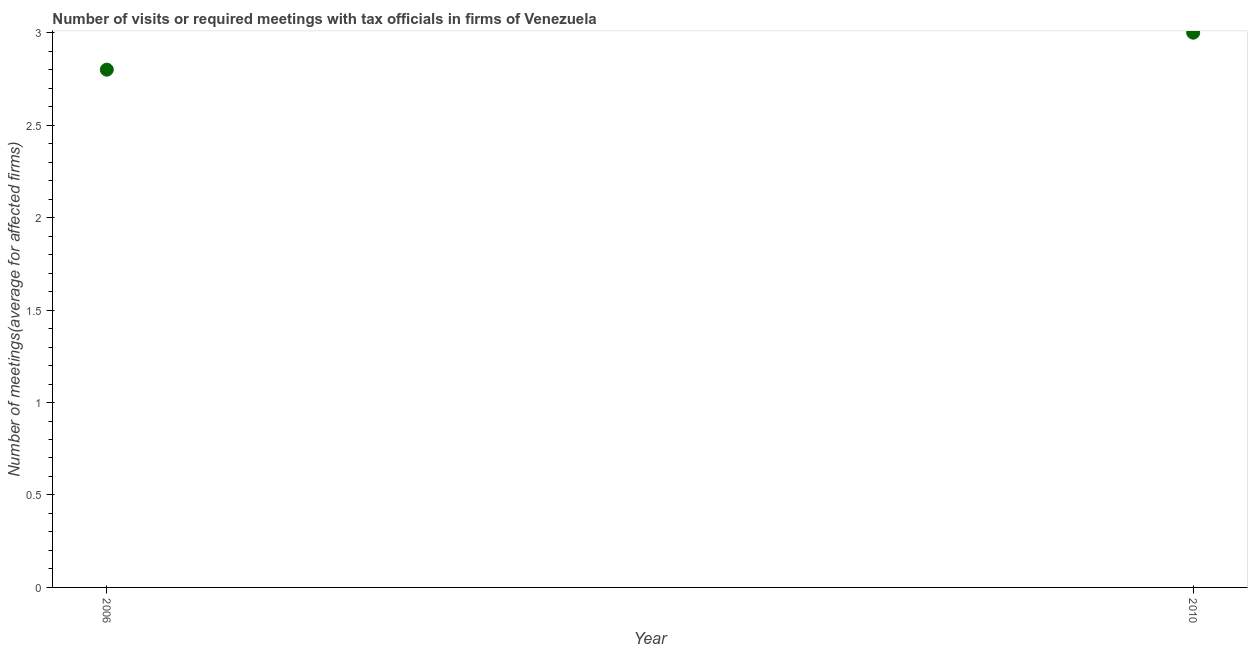What is the number of required meetings with tax officials in 2006?
Provide a succinct answer. 2.8. Across all years, what is the maximum number of required meetings with tax officials?
Offer a very short reply. 3. In which year was the number of required meetings with tax officials minimum?
Your response must be concise. 2006. What is the difference between the number of required meetings with tax officials in 2006 and 2010?
Provide a short and direct response. -0.2. In how many years, is the number of required meetings with tax officials greater than 0.7 ?
Provide a short and direct response. 2. What is the ratio of the number of required meetings with tax officials in 2006 to that in 2010?
Ensure brevity in your answer.  0.93. In how many years, is the number of required meetings with tax officials greater than the average number of required meetings with tax officials taken over all years?
Provide a succinct answer. 1. Does the number of required meetings with tax officials monotonically increase over the years?
Keep it short and to the point. Yes. How many dotlines are there?
Offer a terse response. 1. How many years are there in the graph?
Ensure brevity in your answer.  2. Does the graph contain any zero values?
Your answer should be very brief. No. What is the title of the graph?
Ensure brevity in your answer.  Number of visits or required meetings with tax officials in firms of Venezuela. What is the label or title of the Y-axis?
Give a very brief answer. Number of meetings(average for affected firms). What is the Number of meetings(average for affected firms) in 2006?
Ensure brevity in your answer.  2.8. What is the difference between the Number of meetings(average for affected firms) in 2006 and 2010?
Keep it short and to the point. -0.2. What is the ratio of the Number of meetings(average for affected firms) in 2006 to that in 2010?
Provide a succinct answer. 0.93. 